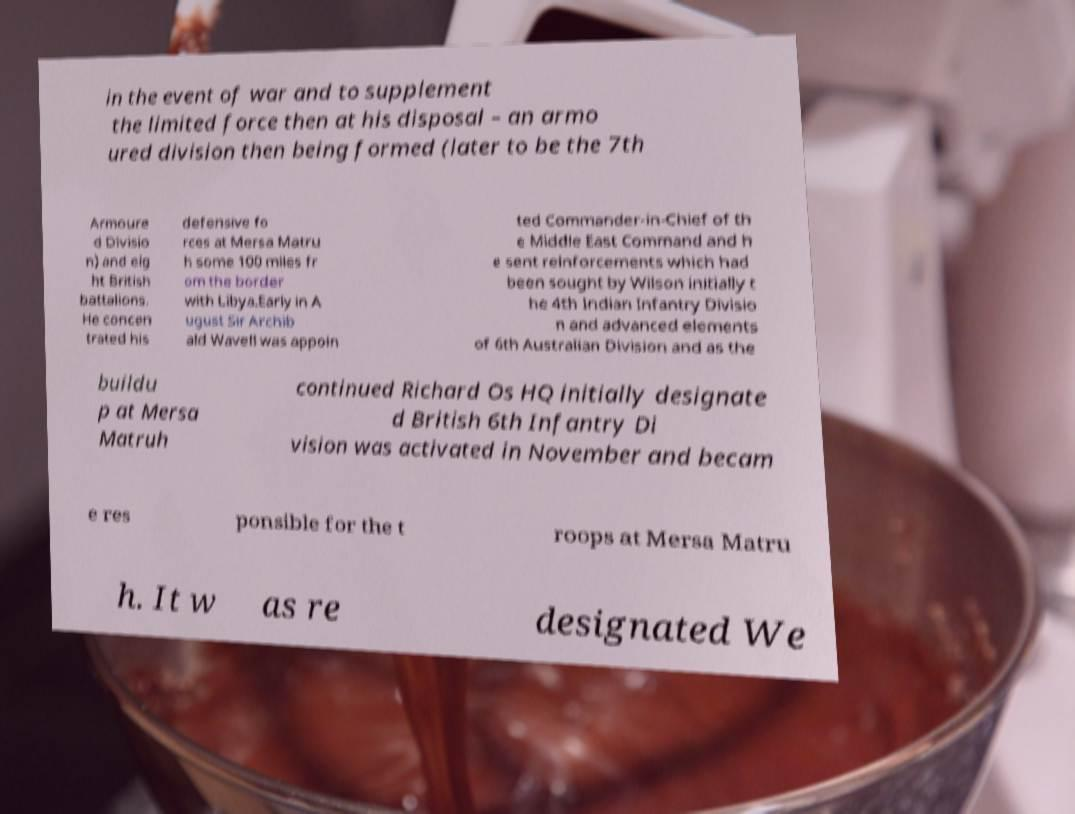Can you read and provide the text displayed in the image?This photo seems to have some interesting text. Can you extract and type it out for me? in the event of war and to supplement the limited force then at his disposal – an armo ured division then being formed (later to be the 7th Armoure d Divisio n) and eig ht British battalions. He concen trated his defensive fo rces at Mersa Matru h some 100 miles fr om the border with Libya.Early in A ugust Sir Archib ald Wavell was appoin ted Commander-in-Chief of th e Middle East Command and h e sent reinforcements which had been sought by Wilson initially t he 4th Indian Infantry Divisio n and advanced elements of 6th Australian Division and as the buildu p at Mersa Matruh continued Richard Os HQ initially designate d British 6th Infantry Di vision was activated in November and becam e res ponsible for the t roops at Mersa Matru h. It w as re designated We 